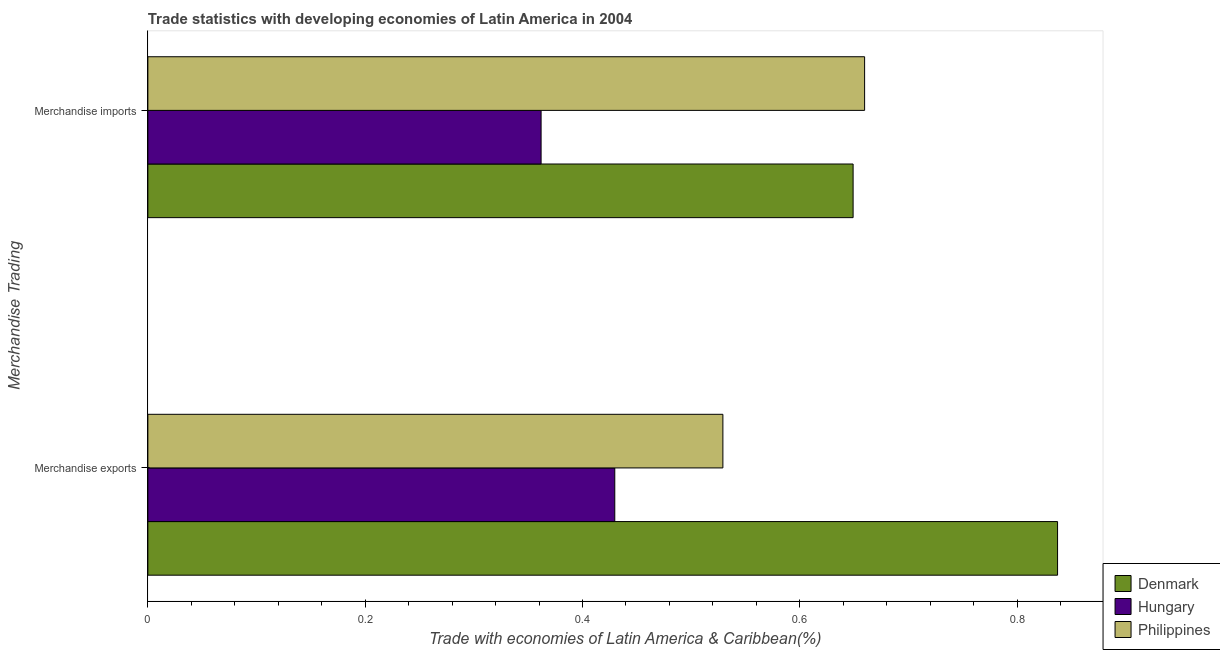Are the number of bars per tick equal to the number of legend labels?
Your answer should be very brief. Yes. Are the number of bars on each tick of the Y-axis equal?
Ensure brevity in your answer.  Yes. What is the label of the 2nd group of bars from the top?
Offer a terse response. Merchandise exports. What is the merchandise exports in Philippines?
Keep it short and to the point. 0.53. Across all countries, what is the maximum merchandise exports?
Offer a terse response. 0.84. Across all countries, what is the minimum merchandise imports?
Your answer should be compact. 0.36. In which country was the merchandise imports maximum?
Provide a short and direct response. Philippines. In which country was the merchandise exports minimum?
Ensure brevity in your answer.  Hungary. What is the total merchandise exports in the graph?
Offer a terse response. 1.8. What is the difference between the merchandise exports in Denmark and that in Hungary?
Ensure brevity in your answer.  0.41. What is the difference between the merchandise imports in Denmark and the merchandise exports in Hungary?
Your answer should be very brief. 0.22. What is the average merchandise exports per country?
Make the answer very short. 0.6. What is the difference between the merchandise imports and merchandise exports in Denmark?
Offer a very short reply. -0.19. What is the ratio of the merchandise exports in Hungary to that in Denmark?
Give a very brief answer. 0.51. What does the 1st bar from the top in Merchandise imports represents?
Provide a succinct answer. Philippines. How many bars are there?
Give a very brief answer. 6. Are all the bars in the graph horizontal?
Provide a succinct answer. Yes. Are the values on the major ticks of X-axis written in scientific E-notation?
Give a very brief answer. No. Does the graph contain grids?
Offer a very short reply. No. Where does the legend appear in the graph?
Offer a very short reply. Bottom right. How many legend labels are there?
Keep it short and to the point. 3. How are the legend labels stacked?
Ensure brevity in your answer.  Vertical. What is the title of the graph?
Your answer should be very brief. Trade statistics with developing economies of Latin America in 2004. Does "Mauritania" appear as one of the legend labels in the graph?
Give a very brief answer. No. What is the label or title of the X-axis?
Keep it short and to the point. Trade with economies of Latin America & Caribbean(%). What is the label or title of the Y-axis?
Provide a short and direct response. Merchandise Trading. What is the Trade with economies of Latin America & Caribbean(%) of Denmark in Merchandise exports?
Ensure brevity in your answer.  0.84. What is the Trade with economies of Latin America & Caribbean(%) in Hungary in Merchandise exports?
Provide a succinct answer. 0.43. What is the Trade with economies of Latin America & Caribbean(%) of Philippines in Merchandise exports?
Your answer should be very brief. 0.53. What is the Trade with economies of Latin America & Caribbean(%) in Denmark in Merchandise imports?
Provide a short and direct response. 0.65. What is the Trade with economies of Latin America & Caribbean(%) in Hungary in Merchandise imports?
Provide a short and direct response. 0.36. What is the Trade with economies of Latin America & Caribbean(%) of Philippines in Merchandise imports?
Your answer should be compact. 0.66. Across all Merchandise Trading, what is the maximum Trade with economies of Latin America & Caribbean(%) of Denmark?
Provide a succinct answer. 0.84. Across all Merchandise Trading, what is the maximum Trade with economies of Latin America & Caribbean(%) in Hungary?
Your answer should be very brief. 0.43. Across all Merchandise Trading, what is the maximum Trade with economies of Latin America & Caribbean(%) of Philippines?
Make the answer very short. 0.66. Across all Merchandise Trading, what is the minimum Trade with economies of Latin America & Caribbean(%) of Denmark?
Provide a succinct answer. 0.65. Across all Merchandise Trading, what is the minimum Trade with economies of Latin America & Caribbean(%) in Hungary?
Make the answer very short. 0.36. Across all Merchandise Trading, what is the minimum Trade with economies of Latin America & Caribbean(%) in Philippines?
Ensure brevity in your answer.  0.53. What is the total Trade with economies of Latin America & Caribbean(%) of Denmark in the graph?
Provide a succinct answer. 1.49. What is the total Trade with economies of Latin America & Caribbean(%) of Hungary in the graph?
Offer a terse response. 0.79. What is the total Trade with economies of Latin America & Caribbean(%) in Philippines in the graph?
Make the answer very short. 1.19. What is the difference between the Trade with economies of Latin America & Caribbean(%) in Denmark in Merchandise exports and that in Merchandise imports?
Give a very brief answer. 0.19. What is the difference between the Trade with economies of Latin America & Caribbean(%) in Hungary in Merchandise exports and that in Merchandise imports?
Ensure brevity in your answer.  0.07. What is the difference between the Trade with economies of Latin America & Caribbean(%) of Philippines in Merchandise exports and that in Merchandise imports?
Offer a very short reply. -0.13. What is the difference between the Trade with economies of Latin America & Caribbean(%) in Denmark in Merchandise exports and the Trade with economies of Latin America & Caribbean(%) in Hungary in Merchandise imports?
Provide a succinct answer. 0.48. What is the difference between the Trade with economies of Latin America & Caribbean(%) of Denmark in Merchandise exports and the Trade with economies of Latin America & Caribbean(%) of Philippines in Merchandise imports?
Ensure brevity in your answer.  0.18. What is the difference between the Trade with economies of Latin America & Caribbean(%) in Hungary in Merchandise exports and the Trade with economies of Latin America & Caribbean(%) in Philippines in Merchandise imports?
Keep it short and to the point. -0.23. What is the average Trade with economies of Latin America & Caribbean(%) in Denmark per Merchandise Trading?
Give a very brief answer. 0.74. What is the average Trade with economies of Latin America & Caribbean(%) in Hungary per Merchandise Trading?
Offer a terse response. 0.4. What is the average Trade with economies of Latin America & Caribbean(%) in Philippines per Merchandise Trading?
Make the answer very short. 0.59. What is the difference between the Trade with economies of Latin America & Caribbean(%) in Denmark and Trade with economies of Latin America & Caribbean(%) in Hungary in Merchandise exports?
Provide a succinct answer. 0.41. What is the difference between the Trade with economies of Latin America & Caribbean(%) of Denmark and Trade with economies of Latin America & Caribbean(%) of Philippines in Merchandise exports?
Offer a terse response. 0.31. What is the difference between the Trade with economies of Latin America & Caribbean(%) in Hungary and Trade with economies of Latin America & Caribbean(%) in Philippines in Merchandise exports?
Offer a terse response. -0.1. What is the difference between the Trade with economies of Latin America & Caribbean(%) of Denmark and Trade with economies of Latin America & Caribbean(%) of Hungary in Merchandise imports?
Your answer should be compact. 0.29. What is the difference between the Trade with economies of Latin America & Caribbean(%) in Denmark and Trade with economies of Latin America & Caribbean(%) in Philippines in Merchandise imports?
Keep it short and to the point. -0.01. What is the difference between the Trade with economies of Latin America & Caribbean(%) in Hungary and Trade with economies of Latin America & Caribbean(%) in Philippines in Merchandise imports?
Offer a terse response. -0.3. What is the ratio of the Trade with economies of Latin America & Caribbean(%) in Denmark in Merchandise exports to that in Merchandise imports?
Ensure brevity in your answer.  1.29. What is the ratio of the Trade with economies of Latin America & Caribbean(%) in Hungary in Merchandise exports to that in Merchandise imports?
Your answer should be very brief. 1.19. What is the ratio of the Trade with economies of Latin America & Caribbean(%) in Philippines in Merchandise exports to that in Merchandise imports?
Ensure brevity in your answer.  0.8. What is the difference between the highest and the second highest Trade with economies of Latin America & Caribbean(%) of Denmark?
Your answer should be compact. 0.19. What is the difference between the highest and the second highest Trade with economies of Latin America & Caribbean(%) of Hungary?
Your answer should be very brief. 0.07. What is the difference between the highest and the second highest Trade with economies of Latin America & Caribbean(%) in Philippines?
Offer a very short reply. 0.13. What is the difference between the highest and the lowest Trade with economies of Latin America & Caribbean(%) in Denmark?
Your answer should be compact. 0.19. What is the difference between the highest and the lowest Trade with economies of Latin America & Caribbean(%) of Hungary?
Your answer should be compact. 0.07. What is the difference between the highest and the lowest Trade with economies of Latin America & Caribbean(%) of Philippines?
Provide a succinct answer. 0.13. 